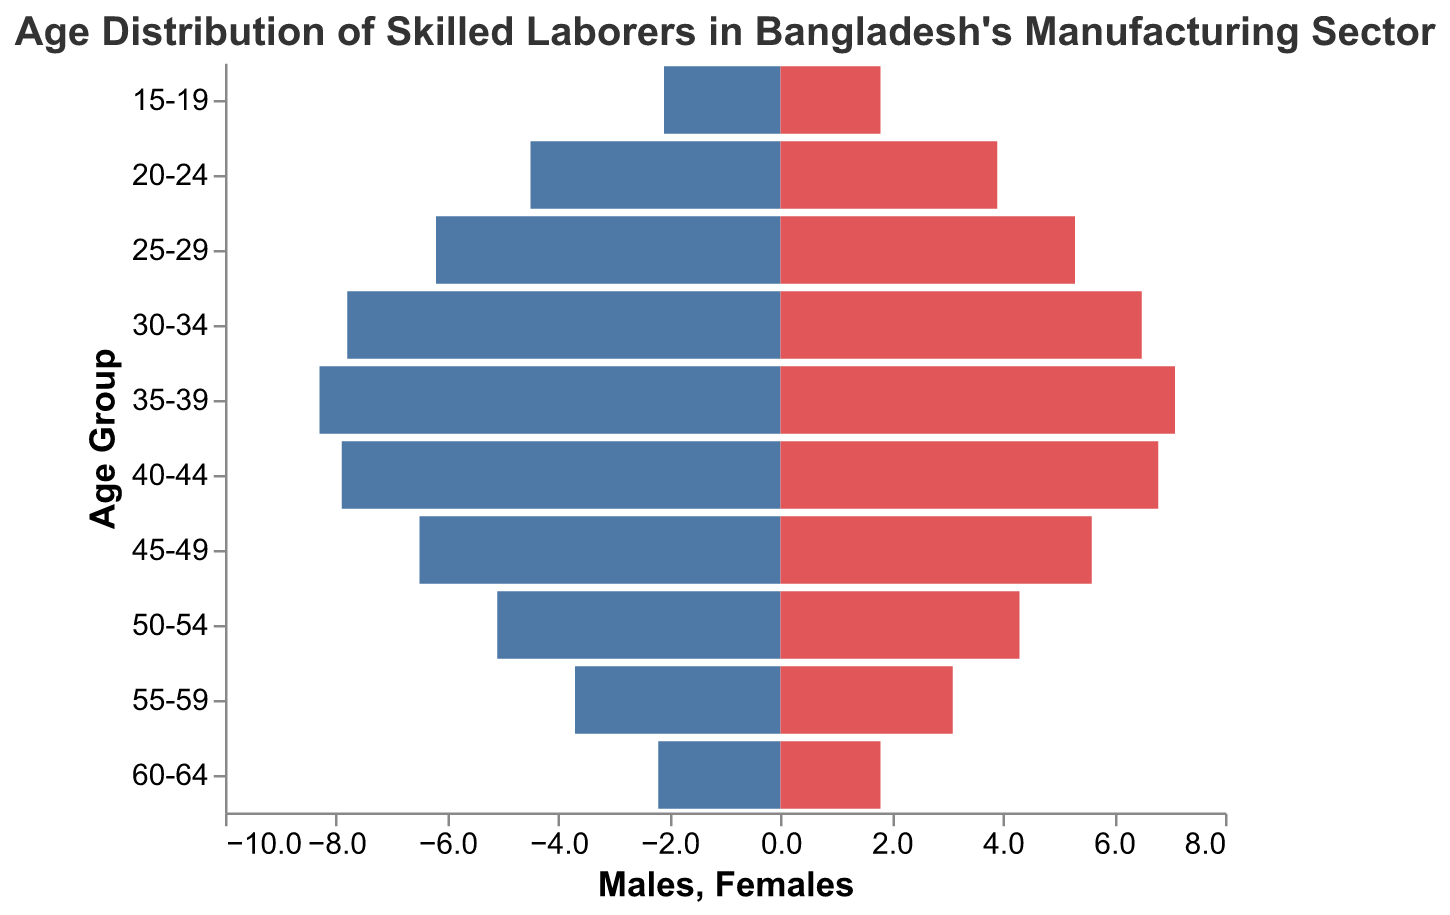What is the title of the figure? The title of the figure is found at the top and is usually larger and bolder than other text elements. It provides a summary of the content displayed in the figure.
Answer: Age Distribution of Skilled Laborers in Bangladesh's Manufacturing Sector Which age group has the highest population of skilled female laborers? By assessing the bars on the right side of the pyramid (representing females), we identify that the bar for the age group "35-39" is the tallest.
Answer: 35-39 How does the male population in the age group 30-34 compare to the female population in the same age group? The bar representing males in the age group 30-34 extends further left than the bar representing females extends to the right, indicating a larger male population.
Answer: The male population is larger What is the combined population of skilled laborers aged 25-29? Add the male (6.2) and female (5.3) values for the age group 25-29 to get the total.
Answer: 11.5 Which age group has the smallest female population? By assessing the shortest bar on the right side of the pyramid, we can see that the age groups 15-19 and 60-64 have the smallest bar lengths.
Answer: 15-19 and 60-64 What is the average population of males aged 45-64? To find the average, add the male populations for the age groups 45-49 (6.5), 50-54 (5.1), 55-59 (3.7), and 60-64 (2.2) and then divide by 4.
Answer: (6.5 + 5.1 + 3.7 + 2.2) / 4 = 4.375 How does the age distribution trend for males compare to females? Observing the bars, both distributions show an increase in population up to the age group 35-39, after which there is a decline. The trend is fairly similar in shape but varies in magnitude.
Answer: Both distributions peak in 35-39 and then decline Which gender has a more consistent population distribution across the age groups? By looking at the lengths of the bars across age groups, the male distribution appears more consistent, with less variation compared to females.
Answer: Males What is the difference in population between the 20-24 age group and the 40-44 age group for males? Subtract the population of males in the 40-44 age group (7.9) from that of the 20-24 age group (4.5).
Answer: 7.9 - 4.5 = 3.4 If you were to target the most populous skilled labor age group for a training program, which age group would you choose? Looking at the tallest bars on both sides of the pyramid, the age group 35-39 has the highest population overall.
Answer: 35-39 